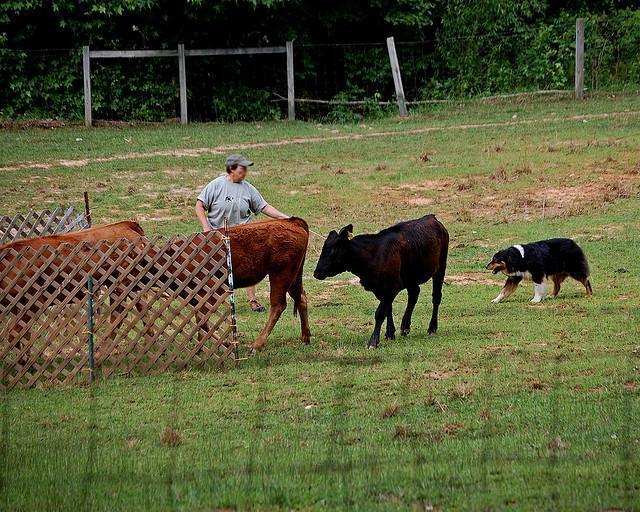How many cows are in the picture?
Give a very brief answer. 3. 